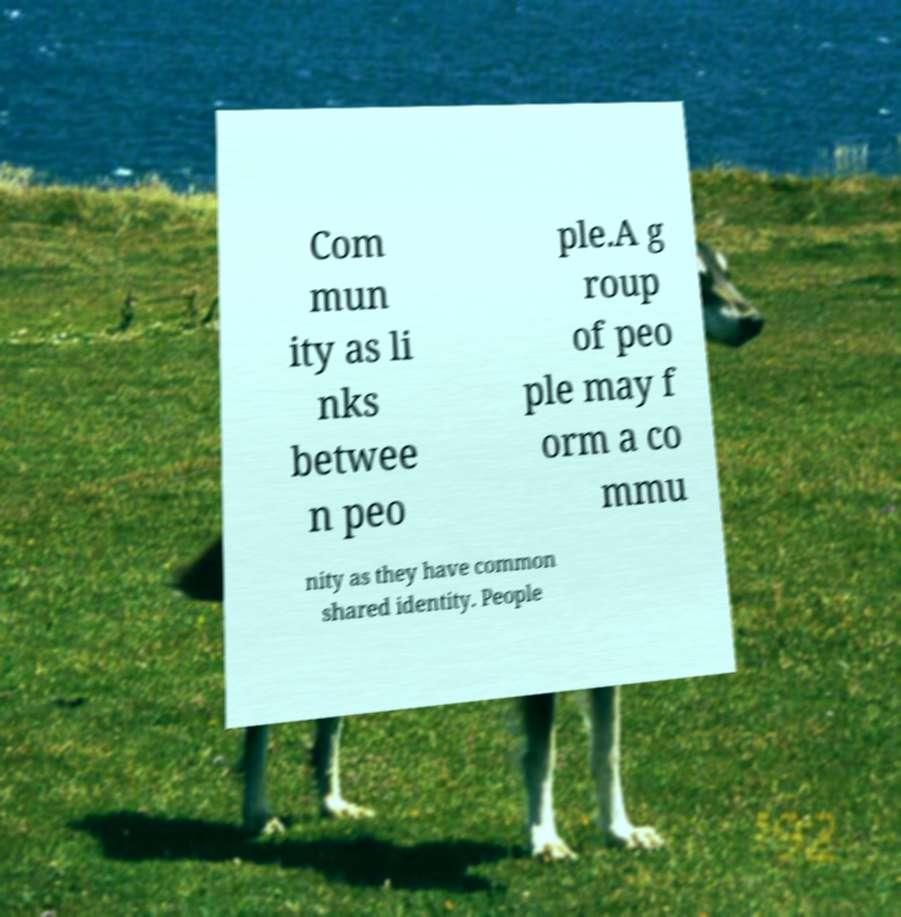Could you extract and type out the text from this image? Com mun ity as li nks betwee n peo ple.A g roup of peo ple may f orm a co mmu nity as they have common shared identity. People 